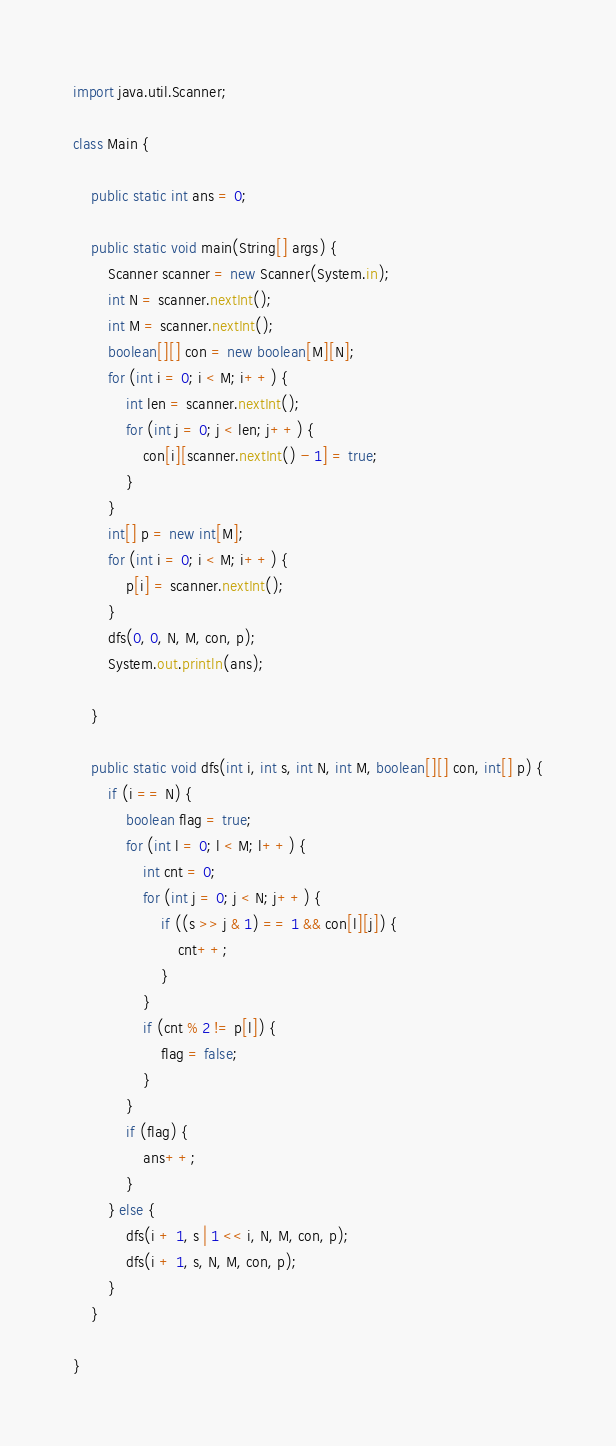<code> <loc_0><loc_0><loc_500><loc_500><_Java_>import java.util.Scanner;

class Main {

    public static int ans = 0;

    public static void main(String[] args) {
        Scanner scanner = new Scanner(System.in);
        int N = scanner.nextInt();
        int M = scanner.nextInt();
        boolean[][] con = new boolean[M][N];
        for (int i = 0; i < M; i++) {
            int len = scanner.nextInt();
            for (int j = 0; j < len; j++) {
                con[i][scanner.nextInt() - 1] = true;
            }
        }
        int[] p = new int[M];
        for (int i = 0; i < M; i++) {
            p[i] = scanner.nextInt();
        }
        dfs(0, 0, N, M, con, p);
        System.out.println(ans);

    }

    public static void dfs(int i, int s, int N, int M, boolean[][] con, int[] p) {
        if (i == N) {
            boolean flag = true;
            for (int l = 0; l < M; l++) {
                int cnt = 0;
                for (int j = 0; j < N; j++) {
                    if ((s >> j & 1) == 1 && con[l][j]) {
                        cnt++;
                    }
                }
                if (cnt % 2 != p[l]) {
                    flag = false;
                }
            }
            if (flag) {
                ans++;
            }
        } else {
            dfs(i + 1, s | 1 << i, N, M, con, p);
            dfs(i + 1, s, N, M, con, p);
        }
    }

}
</code> 